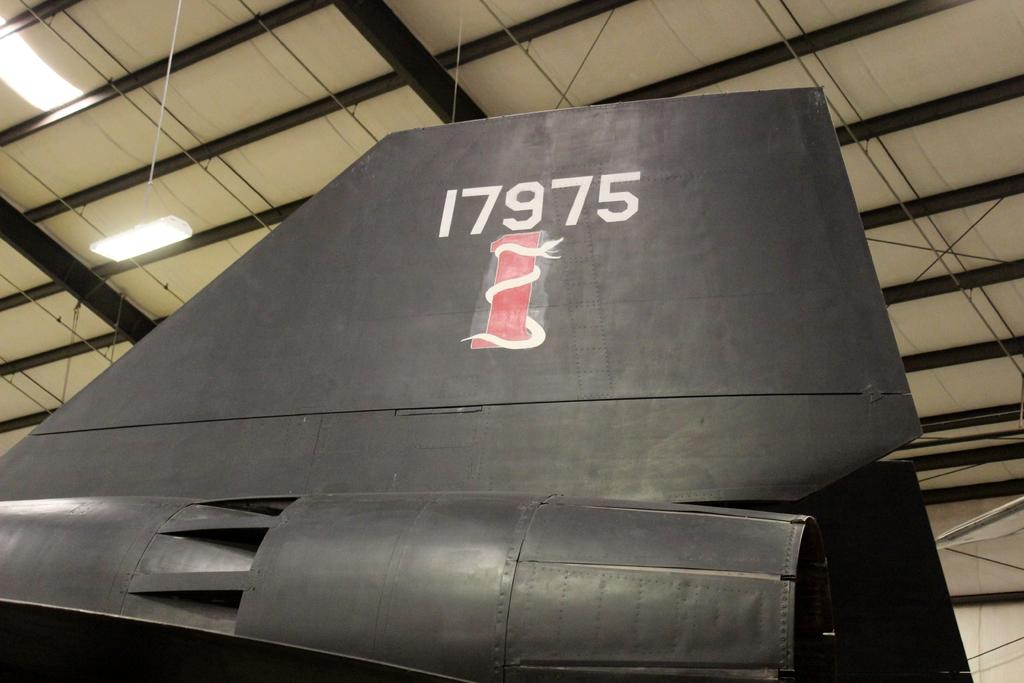What number is on the plane?
Your response must be concise. 17975. 